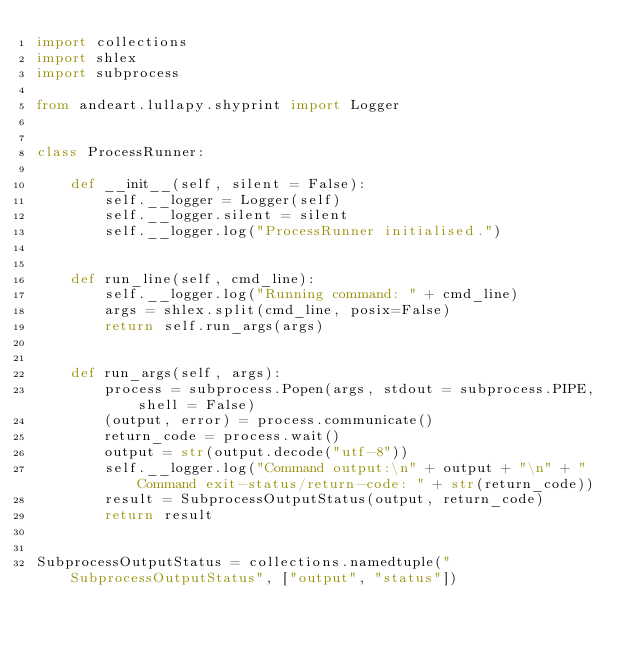<code> <loc_0><loc_0><loc_500><loc_500><_Python_>import collections
import shlex
import subprocess

from andeart.lullapy.shyprint import Logger


class ProcessRunner:

    def __init__(self, silent = False):
        self.__logger = Logger(self)
        self.__logger.silent = silent
        self.__logger.log("ProcessRunner initialised.")


    def run_line(self, cmd_line):        
        self.__logger.log("Running command: " + cmd_line)
        args = shlex.split(cmd_line, posix=False)
        return self.run_args(args)


    def run_args(self, args):
        process = subprocess.Popen(args, stdout = subprocess.PIPE, shell = False)
        (output, error) = process.communicate()
        return_code = process.wait()
        output = str(output.decode("utf-8"))
        self.__logger.log("Command output:\n" + output + "\n" + "Command exit-status/return-code: " + str(return_code))
        result = SubprocessOutputStatus(output, return_code)
        return result


SubprocessOutputStatus = collections.namedtuple("SubprocessOutputStatus", ["output", "status"])
</code> 